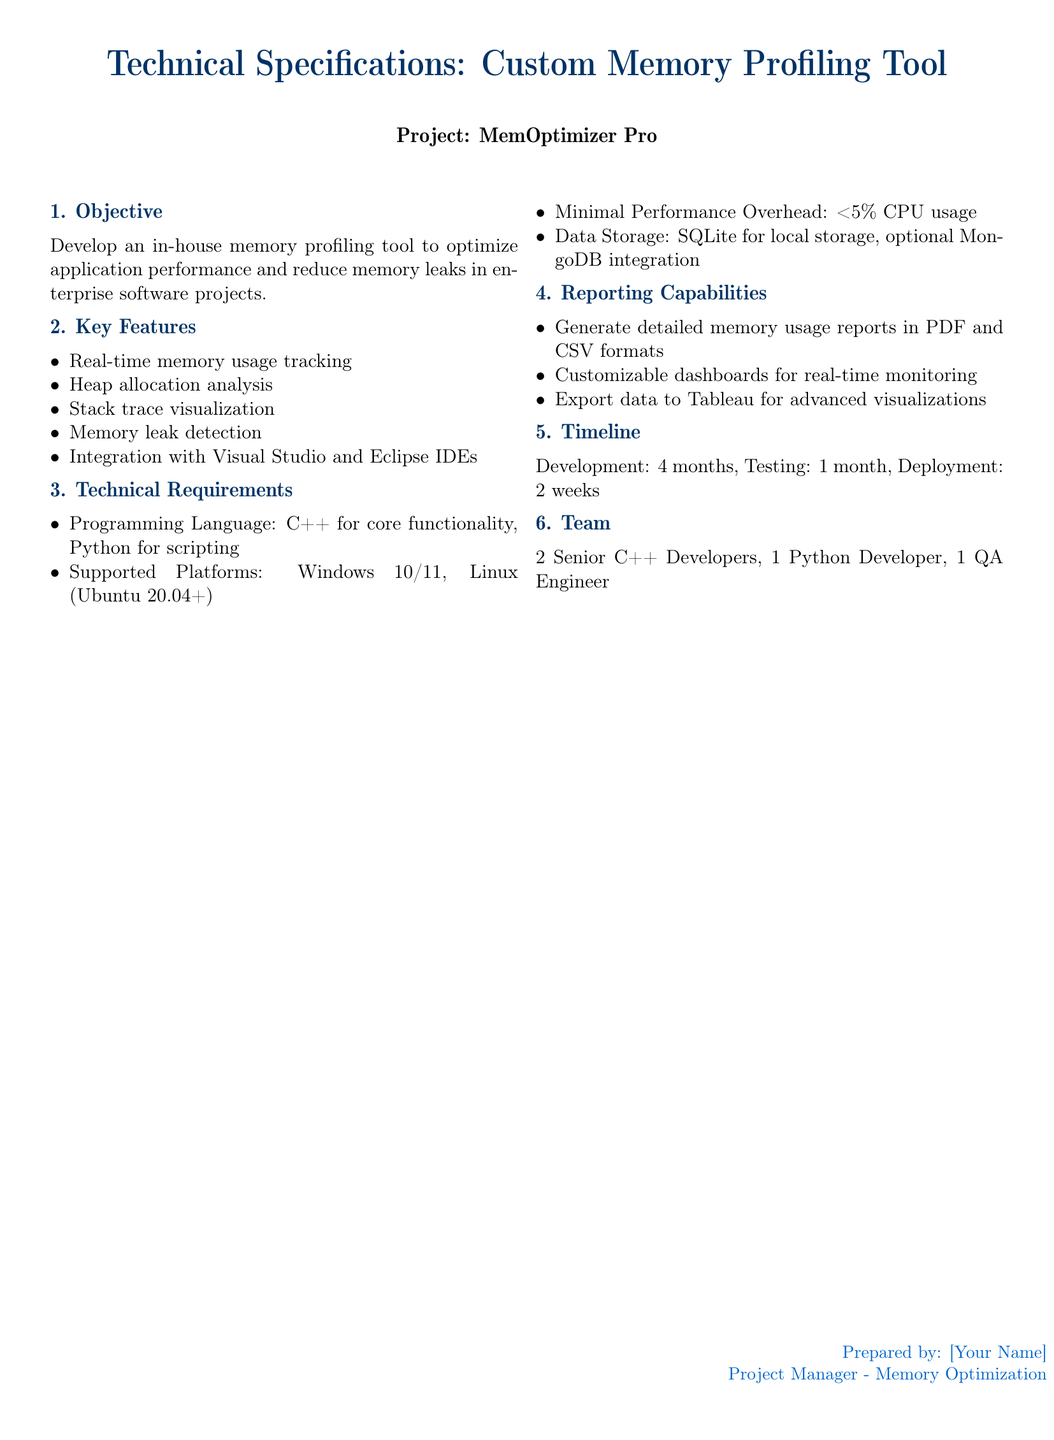What is the project name? The project name is mentioned in the document's subtitle, which is "MemOptimizer Pro."
Answer: MemOptimizer Pro How many developers are on the team? The team composition includes a total of four developers specified in the document.
Answer: 4 What programming languages are used? The programming languages mentioned for the tool are specified under technical requirements.
Answer: C++ and Python What is the timing for development? The document specifies the timeline for development in months.
Answer: 4 months What is the maximum acceptable CPU usage? The document states the performance overhead requirements under technical specifications.
Answer: less than 5 percent Which platforms are supported? The supported platforms are detailed in the technical specifications section.
Answer: Windows 10/11, Linux What type of reports can be generated? The reporting capabilities include formats for generating reports as mentioned in the document.
Answer: PDF and CSV What is the testing duration? The timeline section outlines the duration for testing before the deployment phase.
Answer: 1 month What is required for data storage? Data storage requirements are detailed under technical requirements in the document.
Answer: SQLite and optional MongoDB 